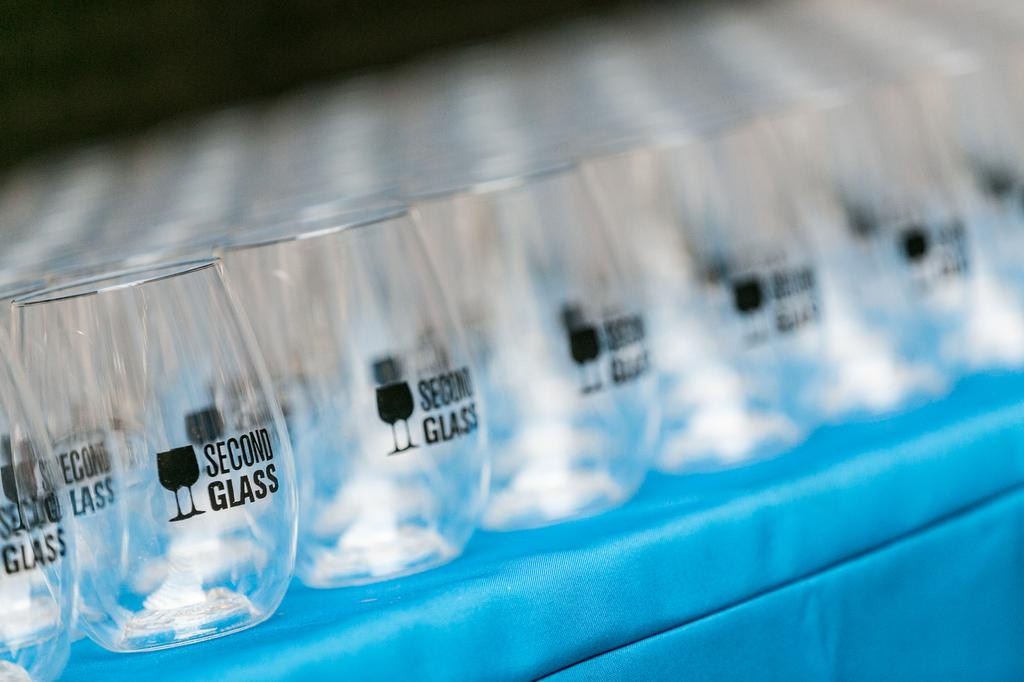<image>
Create a compact narrative representing the image presented. Rows of shot glasses that reads second glass 